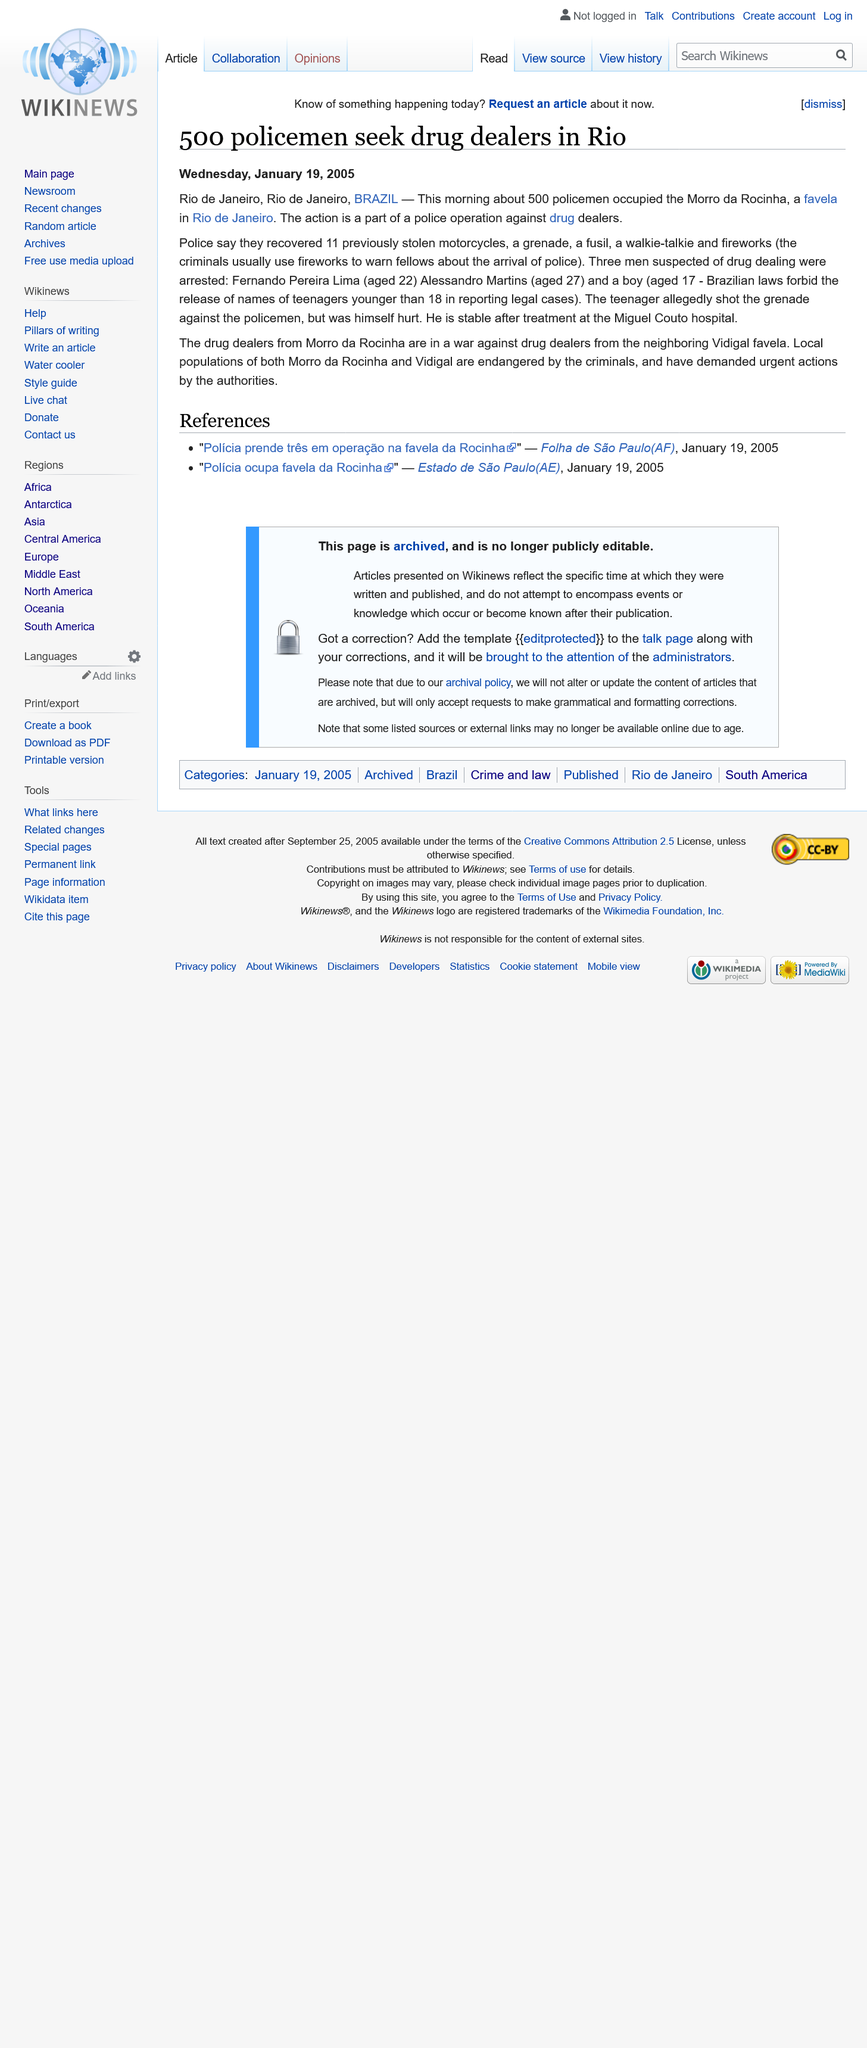Mention a couple of crucial points in this snapshot. There are approximately 500 police officers actively seeking to apprehend drug dealers in Rio de Janeiro. Three individuals who were suspected of drug dealing were arrested. On January 19, 2005, approximately 500 policemen occupied the Morro da Rocinha. 